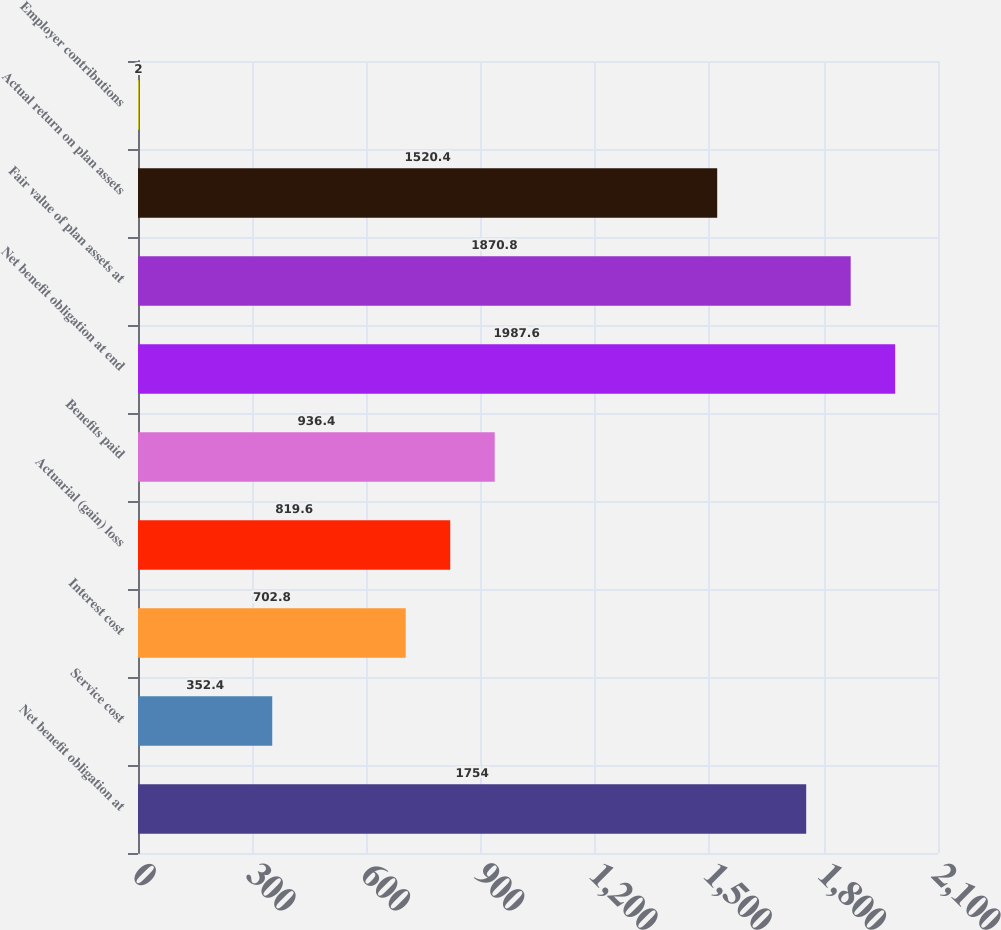Convert chart. <chart><loc_0><loc_0><loc_500><loc_500><bar_chart><fcel>Net benefit obligation at<fcel>Service cost<fcel>Interest cost<fcel>Actuarial (gain) loss<fcel>Benefits paid<fcel>Net benefit obligation at end<fcel>Fair value of plan assets at<fcel>Actual return on plan assets<fcel>Employer contributions<nl><fcel>1754<fcel>352.4<fcel>702.8<fcel>819.6<fcel>936.4<fcel>1987.6<fcel>1870.8<fcel>1520.4<fcel>2<nl></chart> 